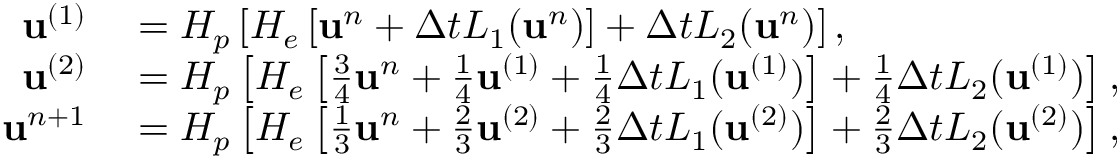Convert formula to latex. <formula><loc_0><loc_0><loc_500><loc_500>\begin{array} { r l } { u ^ { ( 1 ) } } & = H _ { p } \left [ H _ { e } \left [ u ^ { n } + \Delta t L _ { 1 } ( u ^ { n } ) \right ] + \Delta t L _ { 2 } ( u ^ { n } ) \right ] , } \\ { u ^ { ( 2 ) } } & = H _ { p } \left [ H _ { e } \left [ \frac { 3 } { 4 } u ^ { n } + \frac { 1 } { 4 } u ^ { ( 1 ) } + \frac { 1 } { 4 } \Delta t L _ { 1 } ( u ^ { ( 1 ) } ) \right ] + \frac { 1 } { 4 } \Delta t L _ { 2 } ( u ^ { ( 1 ) } ) \right ] , } \\ { u ^ { n + 1 } } & = H _ { p } \left [ H _ { e } \left [ \frac { 1 } { 3 } u ^ { n } + \frac { 2 } { 3 } u ^ { ( 2 ) } + \frac { 2 } { 3 } \Delta t L _ { 1 } ( u ^ { ( 2 ) } ) \right ] + \frac { 2 } { 3 } \Delta t L _ { 2 } ( u ^ { ( 2 ) } ) \right ] , } \end{array}</formula> 